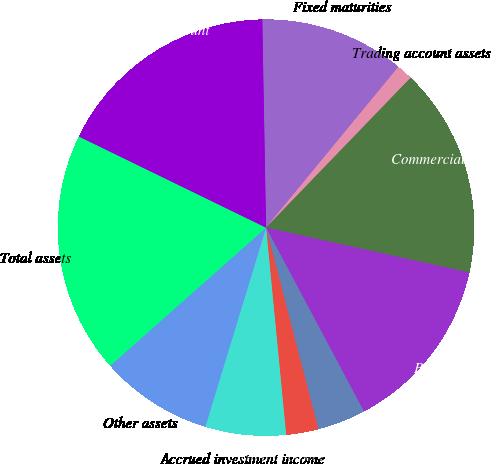Convert chart. <chart><loc_0><loc_0><loc_500><loc_500><pie_chart><fcel>Fixed maturities<fcel>Trading account assets<fcel>Commercial mortgage and other<fcel>Policy loans<fcel>Short-term investments<fcel>Cash and cash equivalents<fcel>Accrued investment income<fcel>Other assets<fcel>Total assets<fcel>Policyholders' account<nl><fcel>11.25%<fcel>1.25%<fcel>16.25%<fcel>13.75%<fcel>3.75%<fcel>2.5%<fcel>6.25%<fcel>8.75%<fcel>18.75%<fcel>17.5%<nl></chart> 